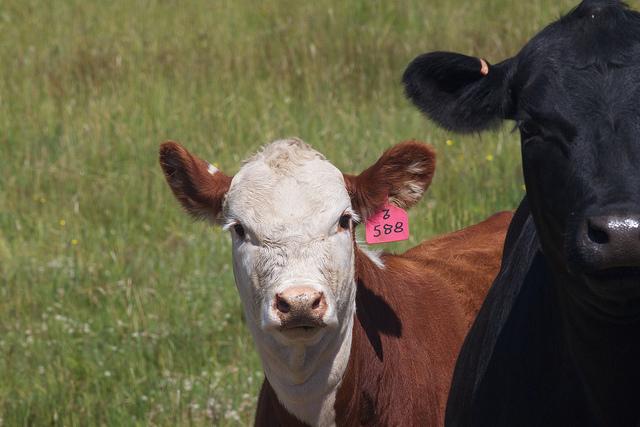Is there a horny cow?
Quick response, please. No. How was the lamp on the left marked?
Be succinct. Tag. What animal is this?
Answer briefly. Cow. What number is seen?
Answer briefly. 588. What kind of animal is this?
Be succinct. Cow. 